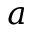<formula> <loc_0><loc_0><loc_500><loc_500>a</formula> 